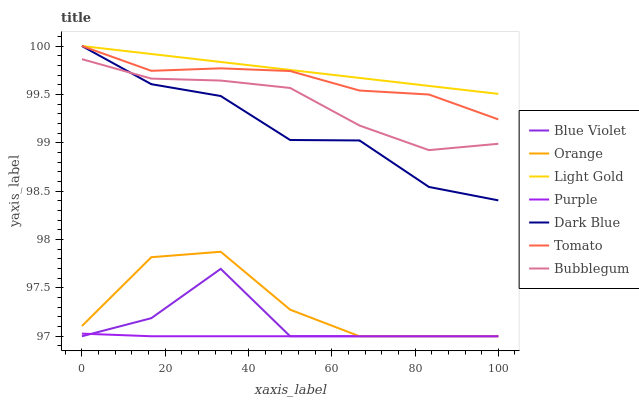Does Bubblegum have the minimum area under the curve?
Answer yes or no. No. Does Bubblegum have the maximum area under the curve?
Answer yes or no. No. Is Purple the smoothest?
Answer yes or no. No. Is Purple the roughest?
Answer yes or no. No. Does Bubblegum have the lowest value?
Answer yes or no. No. Does Bubblegum have the highest value?
Answer yes or no. No. Is Purple less than Tomato?
Answer yes or no. Yes. Is Dark Blue greater than Purple?
Answer yes or no. Yes. Does Purple intersect Tomato?
Answer yes or no. No. 